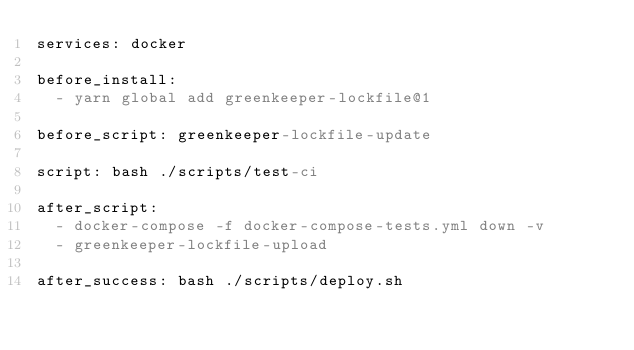Convert code to text. <code><loc_0><loc_0><loc_500><loc_500><_YAML_>services: docker

before_install:
  - yarn global add greenkeeper-lockfile@1

before_script: greenkeeper-lockfile-update

script: bash ./scripts/test-ci

after_script:
  - docker-compose -f docker-compose-tests.yml down -v
  - greenkeeper-lockfile-upload

after_success: bash ./scripts/deploy.sh
</code> 